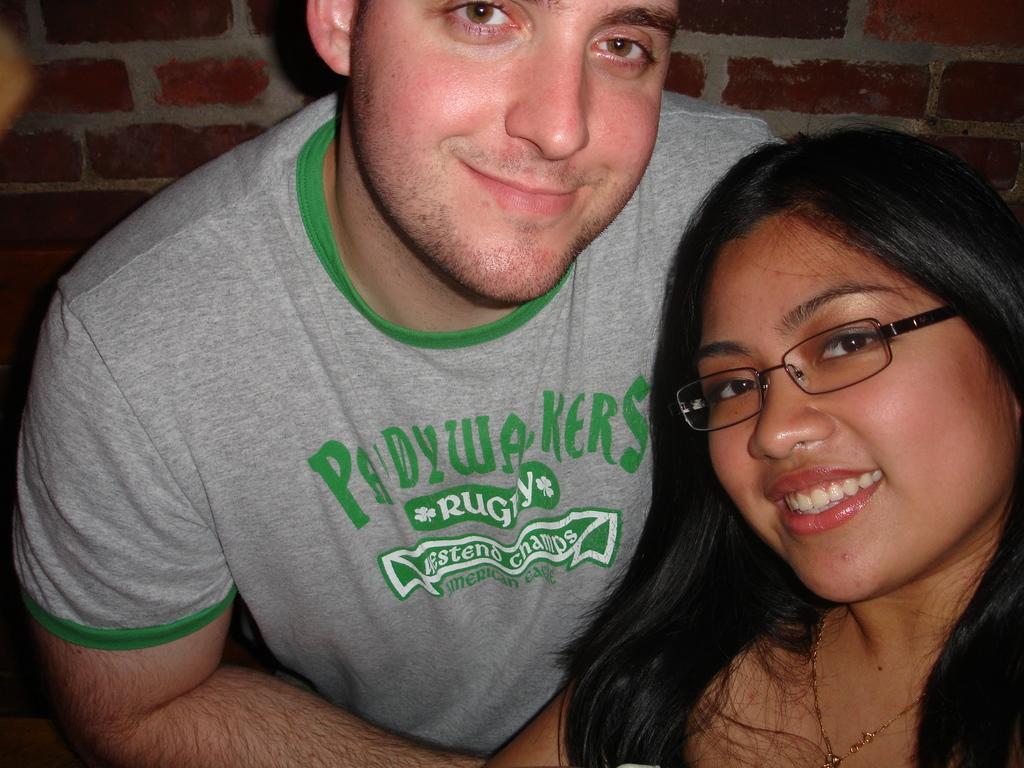In one or two sentences, can you explain what this image depicts? In the foreground of this image, there is a woman and a man posing to the camera. In the background, there is a brick wall. 